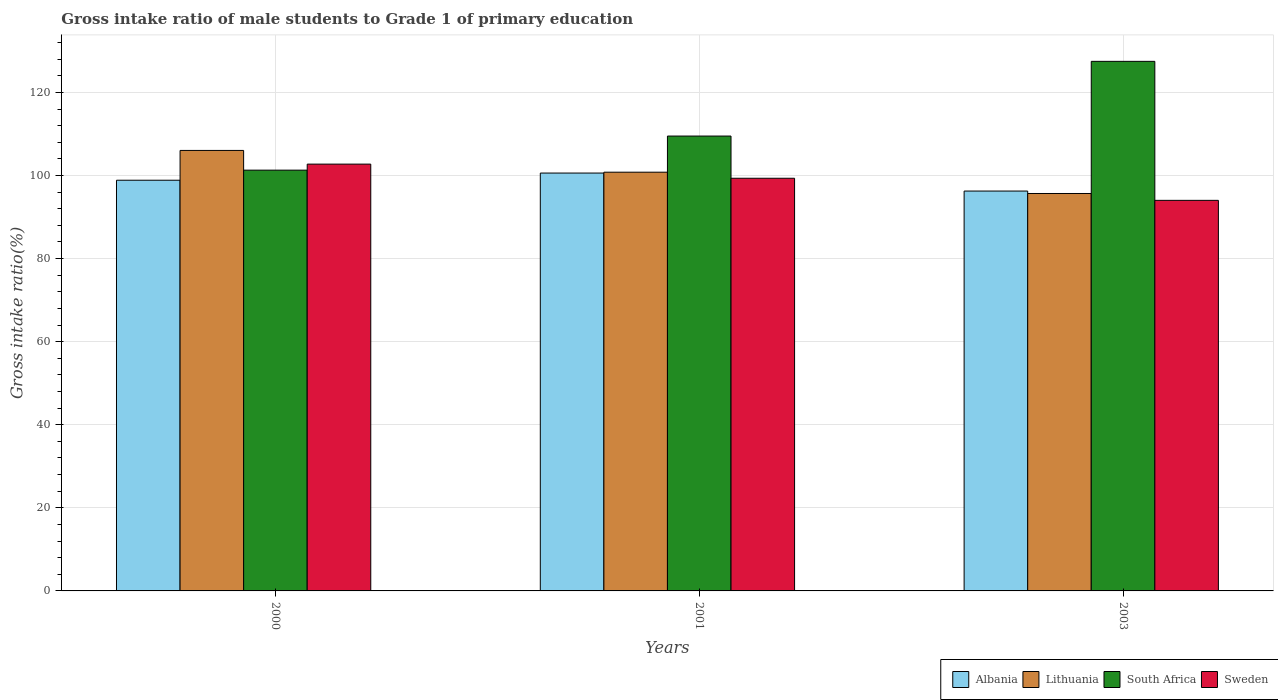How many different coloured bars are there?
Give a very brief answer. 4. Are the number of bars per tick equal to the number of legend labels?
Offer a terse response. Yes. Are the number of bars on each tick of the X-axis equal?
Keep it short and to the point. Yes. How many bars are there on the 3rd tick from the left?
Provide a short and direct response. 4. What is the gross intake ratio in Lithuania in 2003?
Your answer should be very brief. 95.67. Across all years, what is the maximum gross intake ratio in Sweden?
Provide a short and direct response. 102.74. Across all years, what is the minimum gross intake ratio in Lithuania?
Ensure brevity in your answer.  95.67. In which year was the gross intake ratio in Sweden maximum?
Give a very brief answer. 2000. What is the total gross intake ratio in Albania in the graph?
Your answer should be very brief. 295.71. What is the difference between the gross intake ratio in Sweden in 2000 and that in 2003?
Offer a very short reply. 8.72. What is the difference between the gross intake ratio in Albania in 2000 and the gross intake ratio in South Africa in 2001?
Your response must be concise. -10.64. What is the average gross intake ratio in Albania per year?
Give a very brief answer. 98.57. In the year 2003, what is the difference between the gross intake ratio in Albania and gross intake ratio in South Africa?
Your answer should be very brief. -31.22. What is the ratio of the gross intake ratio in Albania in 2001 to that in 2003?
Your answer should be compact. 1.05. Is the gross intake ratio in Sweden in 2000 less than that in 2003?
Make the answer very short. No. What is the difference between the highest and the second highest gross intake ratio in Albania?
Give a very brief answer. 1.73. What is the difference between the highest and the lowest gross intake ratio in South Africa?
Provide a short and direct response. 26.19. Is it the case that in every year, the sum of the gross intake ratio in Lithuania and gross intake ratio in Albania is greater than the sum of gross intake ratio in South Africa and gross intake ratio in Sweden?
Provide a short and direct response. No. What does the 4th bar from the left in 2003 represents?
Ensure brevity in your answer.  Sweden. What does the 4th bar from the right in 2003 represents?
Provide a succinct answer. Albania. How many years are there in the graph?
Your answer should be very brief. 3. What is the difference between two consecutive major ticks on the Y-axis?
Your answer should be very brief. 20. Does the graph contain grids?
Ensure brevity in your answer.  Yes. Where does the legend appear in the graph?
Keep it short and to the point. Bottom right. How are the legend labels stacked?
Provide a short and direct response. Horizontal. What is the title of the graph?
Your response must be concise. Gross intake ratio of male students to Grade 1 of primary education. What is the label or title of the Y-axis?
Offer a very short reply. Gross intake ratio(%). What is the Gross intake ratio(%) of Albania in 2000?
Your response must be concise. 98.86. What is the Gross intake ratio(%) in Lithuania in 2000?
Provide a short and direct response. 106.04. What is the Gross intake ratio(%) of South Africa in 2000?
Your answer should be very brief. 101.29. What is the Gross intake ratio(%) in Sweden in 2000?
Your answer should be very brief. 102.74. What is the Gross intake ratio(%) of Albania in 2001?
Offer a terse response. 100.59. What is the Gross intake ratio(%) in Lithuania in 2001?
Ensure brevity in your answer.  100.8. What is the Gross intake ratio(%) in South Africa in 2001?
Offer a terse response. 109.5. What is the Gross intake ratio(%) of Sweden in 2001?
Provide a succinct answer. 99.34. What is the Gross intake ratio(%) of Albania in 2003?
Your answer should be very brief. 96.26. What is the Gross intake ratio(%) in Lithuania in 2003?
Give a very brief answer. 95.67. What is the Gross intake ratio(%) of South Africa in 2003?
Your answer should be compact. 127.48. What is the Gross intake ratio(%) in Sweden in 2003?
Your response must be concise. 94.02. Across all years, what is the maximum Gross intake ratio(%) of Albania?
Give a very brief answer. 100.59. Across all years, what is the maximum Gross intake ratio(%) of Lithuania?
Provide a succinct answer. 106.04. Across all years, what is the maximum Gross intake ratio(%) of South Africa?
Your answer should be very brief. 127.48. Across all years, what is the maximum Gross intake ratio(%) in Sweden?
Provide a short and direct response. 102.74. Across all years, what is the minimum Gross intake ratio(%) in Albania?
Offer a terse response. 96.26. Across all years, what is the minimum Gross intake ratio(%) of Lithuania?
Offer a very short reply. 95.67. Across all years, what is the minimum Gross intake ratio(%) in South Africa?
Ensure brevity in your answer.  101.29. Across all years, what is the minimum Gross intake ratio(%) in Sweden?
Your answer should be compact. 94.02. What is the total Gross intake ratio(%) of Albania in the graph?
Ensure brevity in your answer.  295.71. What is the total Gross intake ratio(%) in Lithuania in the graph?
Your answer should be compact. 302.51. What is the total Gross intake ratio(%) in South Africa in the graph?
Your answer should be compact. 338.27. What is the total Gross intake ratio(%) of Sweden in the graph?
Keep it short and to the point. 296.1. What is the difference between the Gross intake ratio(%) of Albania in 2000 and that in 2001?
Your answer should be compact. -1.73. What is the difference between the Gross intake ratio(%) in Lithuania in 2000 and that in 2001?
Your response must be concise. 5.24. What is the difference between the Gross intake ratio(%) in South Africa in 2000 and that in 2001?
Your response must be concise. -8.21. What is the difference between the Gross intake ratio(%) of Sweden in 2000 and that in 2001?
Offer a terse response. 3.4. What is the difference between the Gross intake ratio(%) of Albania in 2000 and that in 2003?
Offer a terse response. 2.61. What is the difference between the Gross intake ratio(%) of Lithuania in 2000 and that in 2003?
Provide a short and direct response. 10.37. What is the difference between the Gross intake ratio(%) in South Africa in 2000 and that in 2003?
Your answer should be very brief. -26.19. What is the difference between the Gross intake ratio(%) in Sweden in 2000 and that in 2003?
Provide a succinct answer. 8.72. What is the difference between the Gross intake ratio(%) in Albania in 2001 and that in 2003?
Provide a short and direct response. 4.33. What is the difference between the Gross intake ratio(%) in Lithuania in 2001 and that in 2003?
Offer a very short reply. 5.13. What is the difference between the Gross intake ratio(%) of South Africa in 2001 and that in 2003?
Keep it short and to the point. -17.98. What is the difference between the Gross intake ratio(%) in Sweden in 2001 and that in 2003?
Your answer should be very brief. 5.32. What is the difference between the Gross intake ratio(%) of Albania in 2000 and the Gross intake ratio(%) of Lithuania in 2001?
Your answer should be very brief. -1.93. What is the difference between the Gross intake ratio(%) in Albania in 2000 and the Gross intake ratio(%) in South Africa in 2001?
Ensure brevity in your answer.  -10.64. What is the difference between the Gross intake ratio(%) of Albania in 2000 and the Gross intake ratio(%) of Sweden in 2001?
Your answer should be compact. -0.47. What is the difference between the Gross intake ratio(%) in Lithuania in 2000 and the Gross intake ratio(%) in South Africa in 2001?
Your answer should be compact. -3.46. What is the difference between the Gross intake ratio(%) in Lithuania in 2000 and the Gross intake ratio(%) in Sweden in 2001?
Your answer should be compact. 6.7. What is the difference between the Gross intake ratio(%) of South Africa in 2000 and the Gross intake ratio(%) of Sweden in 2001?
Your answer should be compact. 1.95. What is the difference between the Gross intake ratio(%) of Albania in 2000 and the Gross intake ratio(%) of Lithuania in 2003?
Your response must be concise. 3.19. What is the difference between the Gross intake ratio(%) in Albania in 2000 and the Gross intake ratio(%) in South Africa in 2003?
Your response must be concise. -28.62. What is the difference between the Gross intake ratio(%) of Albania in 2000 and the Gross intake ratio(%) of Sweden in 2003?
Offer a very short reply. 4.84. What is the difference between the Gross intake ratio(%) in Lithuania in 2000 and the Gross intake ratio(%) in South Africa in 2003?
Ensure brevity in your answer.  -21.44. What is the difference between the Gross intake ratio(%) of Lithuania in 2000 and the Gross intake ratio(%) of Sweden in 2003?
Provide a short and direct response. 12.02. What is the difference between the Gross intake ratio(%) in South Africa in 2000 and the Gross intake ratio(%) in Sweden in 2003?
Provide a short and direct response. 7.27. What is the difference between the Gross intake ratio(%) in Albania in 2001 and the Gross intake ratio(%) in Lithuania in 2003?
Your response must be concise. 4.92. What is the difference between the Gross intake ratio(%) of Albania in 2001 and the Gross intake ratio(%) of South Africa in 2003?
Provide a short and direct response. -26.89. What is the difference between the Gross intake ratio(%) in Albania in 2001 and the Gross intake ratio(%) in Sweden in 2003?
Your response must be concise. 6.57. What is the difference between the Gross intake ratio(%) of Lithuania in 2001 and the Gross intake ratio(%) of South Africa in 2003?
Offer a very short reply. -26.68. What is the difference between the Gross intake ratio(%) in Lithuania in 2001 and the Gross intake ratio(%) in Sweden in 2003?
Your answer should be very brief. 6.78. What is the difference between the Gross intake ratio(%) in South Africa in 2001 and the Gross intake ratio(%) in Sweden in 2003?
Offer a terse response. 15.48. What is the average Gross intake ratio(%) in Albania per year?
Your answer should be very brief. 98.57. What is the average Gross intake ratio(%) of Lithuania per year?
Provide a succinct answer. 100.84. What is the average Gross intake ratio(%) in South Africa per year?
Keep it short and to the point. 112.76. What is the average Gross intake ratio(%) in Sweden per year?
Keep it short and to the point. 98.7. In the year 2000, what is the difference between the Gross intake ratio(%) of Albania and Gross intake ratio(%) of Lithuania?
Give a very brief answer. -7.18. In the year 2000, what is the difference between the Gross intake ratio(%) in Albania and Gross intake ratio(%) in South Africa?
Your response must be concise. -2.43. In the year 2000, what is the difference between the Gross intake ratio(%) in Albania and Gross intake ratio(%) in Sweden?
Your response must be concise. -3.88. In the year 2000, what is the difference between the Gross intake ratio(%) in Lithuania and Gross intake ratio(%) in South Africa?
Give a very brief answer. 4.75. In the year 2000, what is the difference between the Gross intake ratio(%) in Lithuania and Gross intake ratio(%) in Sweden?
Provide a short and direct response. 3.3. In the year 2000, what is the difference between the Gross intake ratio(%) of South Africa and Gross intake ratio(%) of Sweden?
Provide a short and direct response. -1.45. In the year 2001, what is the difference between the Gross intake ratio(%) of Albania and Gross intake ratio(%) of Lithuania?
Provide a short and direct response. -0.21. In the year 2001, what is the difference between the Gross intake ratio(%) of Albania and Gross intake ratio(%) of South Africa?
Make the answer very short. -8.91. In the year 2001, what is the difference between the Gross intake ratio(%) of Albania and Gross intake ratio(%) of Sweden?
Give a very brief answer. 1.25. In the year 2001, what is the difference between the Gross intake ratio(%) of Lithuania and Gross intake ratio(%) of South Africa?
Provide a succinct answer. -8.7. In the year 2001, what is the difference between the Gross intake ratio(%) of Lithuania and Gross intake ratio(%) of Sweden?
Your response must be concise. 1.46. In the year 2001, what is the difference between the Gross intake ratio(%) of South Africa and Gross intake ratio(%) of Sweden?
Keep it short and to the point. 10.16. In the year 2003, what is the difference between the Gross intake ratio(%) of Albania and Gross intake ratio(%) of Lithuania?
Provide a short and direct response. 0.59. In the year 2003, what is the difference between the Gross intake ratio(%) in Albania and Gross intake ratio(%) in South Africa?
Your answer should be compact. -31.22. In the year 2003, what is the difference between the Gross intake ratio(%) in Albania and Gross intake ratio(%) in Sweden?
Your answer should be compact. 2.24. In the year 2003, what is the difference between the Gross intake ratio(%) of Lithuania and Gross intake ratio(%) of South Africa?
Ensure brevity in your answer.  -31.81. In the year 2003, what is the difference between the Gross intake ratio(%) of Lithuania and Gross intake ratio(%) of Sweden?
Your response must be concise. 1.65. In the year 2003, what is the difference between the Gross intake ratio(%) in South Africa and Gross intake ratio(%) in Sweden?
Your answer should be compact. 33.46. What is the ratio of the Gross intake ratio(%) in Albania in 2000 to that in 2001?
Ensure brevity in your answer.  0.98. What is the ratio of the Gross intake ratio(%) of Lithuania in 2000 to that in 2001?
Your answer should be very brief. 1.05. What is the ratio of the Gross intake ratio(%) of South Africa in 2000 to that in 2001?
Offer a very short reply. 0.93. What is the ratio of the Gross intake ratio(%) of Sweden in 2000 to that in 2001?
Your response must be concise. 1.03. What is the ratio of the Gross intake ratio(%) in Albania in 2000 to that in 2003?
Provide a succinct answer. 1.03. What is the ratio of the Gross intake ratio(%) of Lithuania in 2000 to that in 2003?
Ensure brevity in your answer.  1.11. What is the ratio of the Gross intake ratio(%) of South Africa in 2000 to that in 2003?
Offer a terse response. 0.79. What is the ratio of the Gross intake ratio(%) in Sweden in 2000 to that in 2003?
Your answer should be compact. 1.09. What is the ratio of the Gross intake ratio(%) in Albania in 2001 to that in 2003?
Your response must be concise. 1.04. What is the ratio of the Gross intake ratio(%) in Lithuania in 2001 to that in 2003?
Make the answer very short. 1.05. What is the ratio of the Gross intake ratio(%) of South Africa in 2001 to that in 2003?
Make the answer very short. 0.86. What is the ratio of the Gross intake ratio(%) in Sweden in 2001 to that in 2003?
Your answer should be very brief. 1.06. What is the difference between the highest and the second highest Gross intake ratio(%) of Albania?
Make the answer very short. 1.73. What is the difference between the highest and the second highest Gross intake ratio(%) of Lithuania?
Make the answer very short. 5.24. What is the difference between the highest and the second highest Gross intake ratio(%) in South Africa?
Make the answer very short. 17.98. What is the difference between the highest and the second highest Gross intake ratio(%) in Sweden?
Your response must be concise. 3.4. What is the difference between the highest and the lowest Gross intake ratio(%) of Albania?
Make the answer very short. 4.33. What is the difference between the highest and the lowest Gross intake ratio(%) in Lithuania?
Keep it short and to the point. 10.37. What is the difference between the highest and the lowest Gross intake ratio(%) of South Africa?
Offer a very short reply. 26.19. What is the difference between the highest and the lowest Gross intake ratio(%) in Sweden?
Provide a short and direct response. 8.72. 